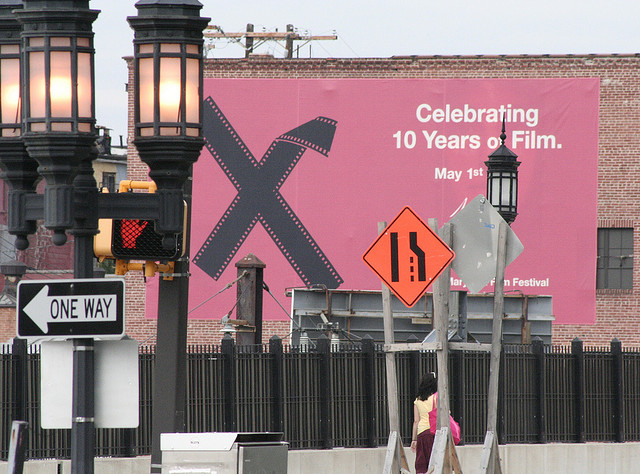Please transcribe the text in this image. Celebrating 10 Years Flim. MAY WAY ONE Festival 1st of 